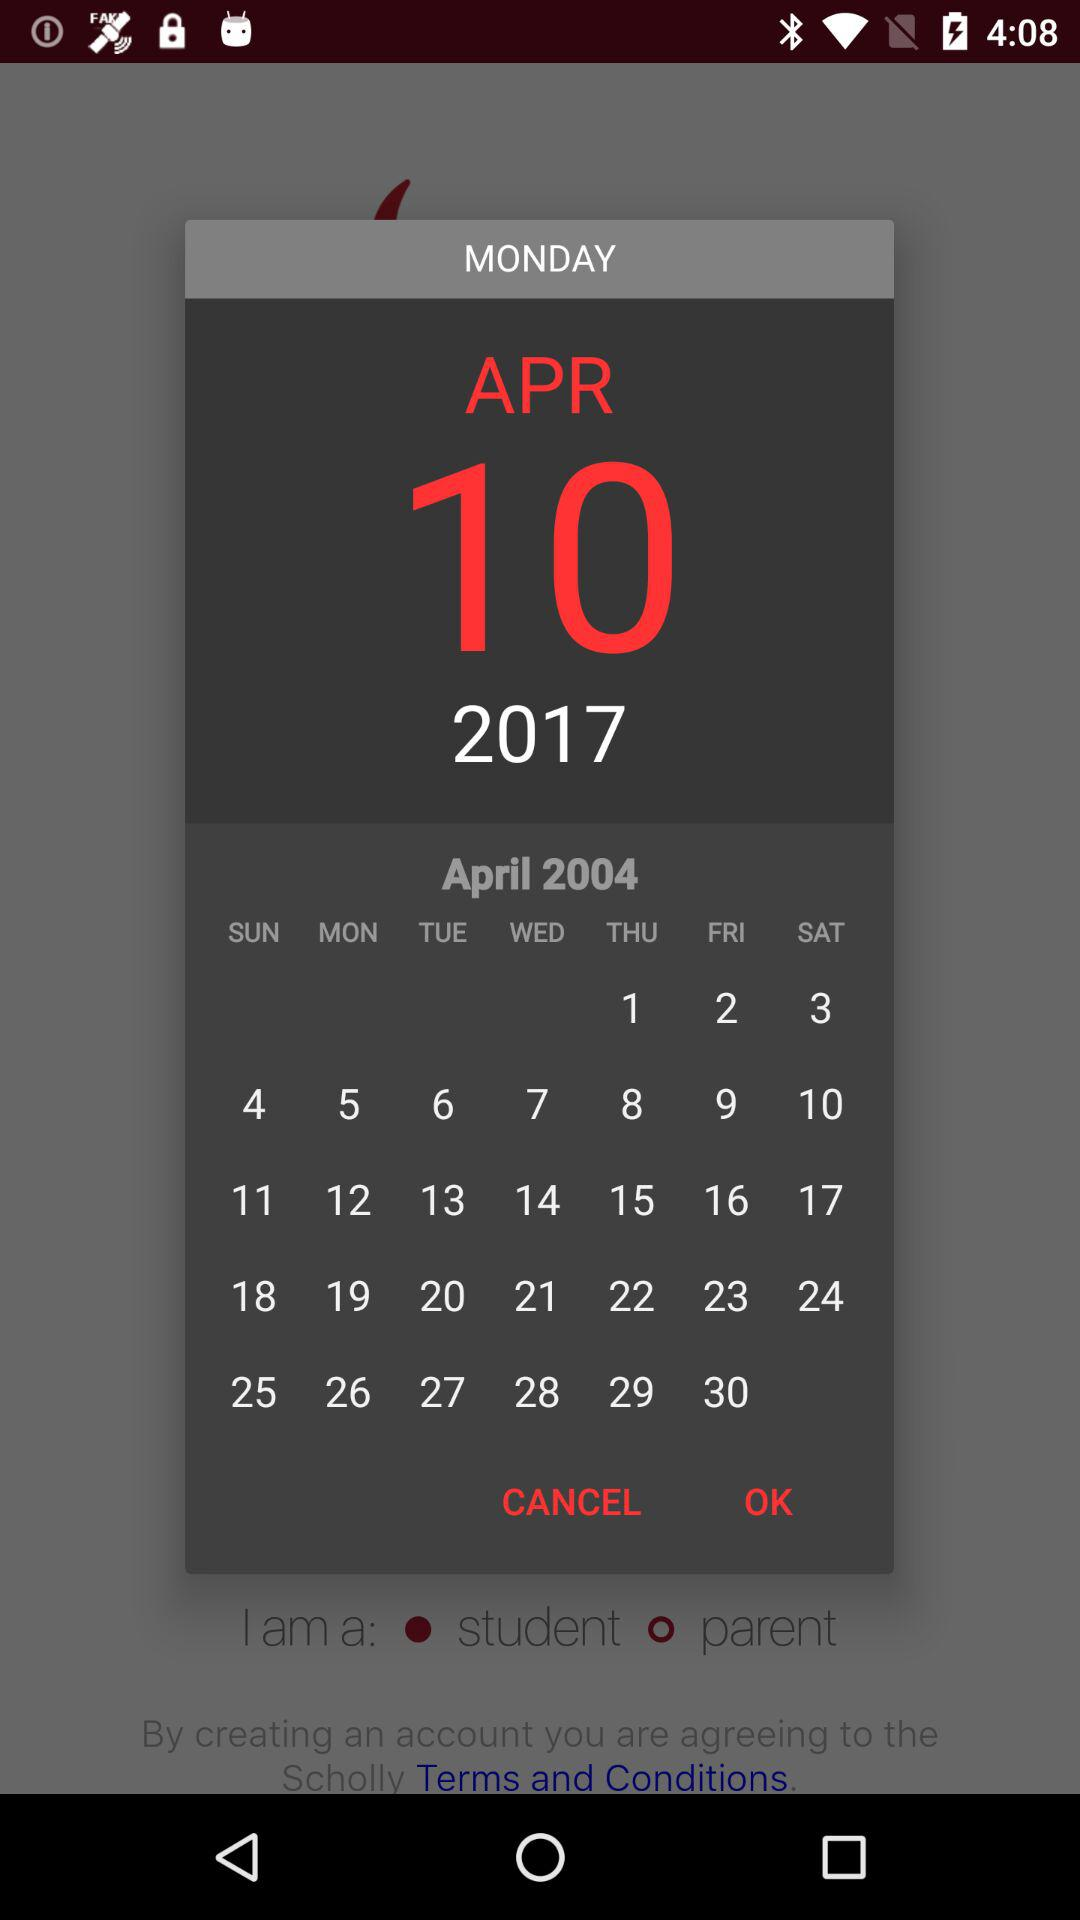Which day of the week does May 10, 2017, fall on?
When the provided information is insufficient, respond with <no answer>. <no answer> 